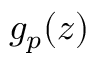<formula> <loc_0><loc_0><loc_500><loc_500>g _ { p } ( z )</formula> 